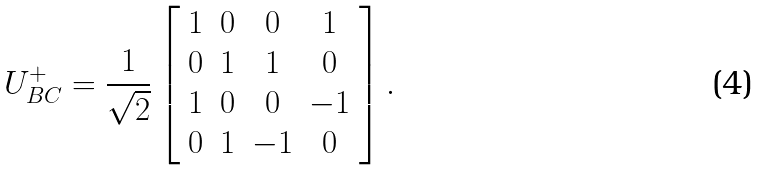<formula> <loc_0><loc_0><loc_500><loc_500>U ^ { + } _ { B C } = \frac { 1 } { \sqrt { 2 } } \left [ \begin{array} { c c c c } 1 & 0 & 0 & 1 \\ 0 & 1 & 1 & 0 \\ 1 & 0 & 0 & - 1 \\ 0 & 1 & - 1 & 0 \\ \end{array} \right ] .</formula> 